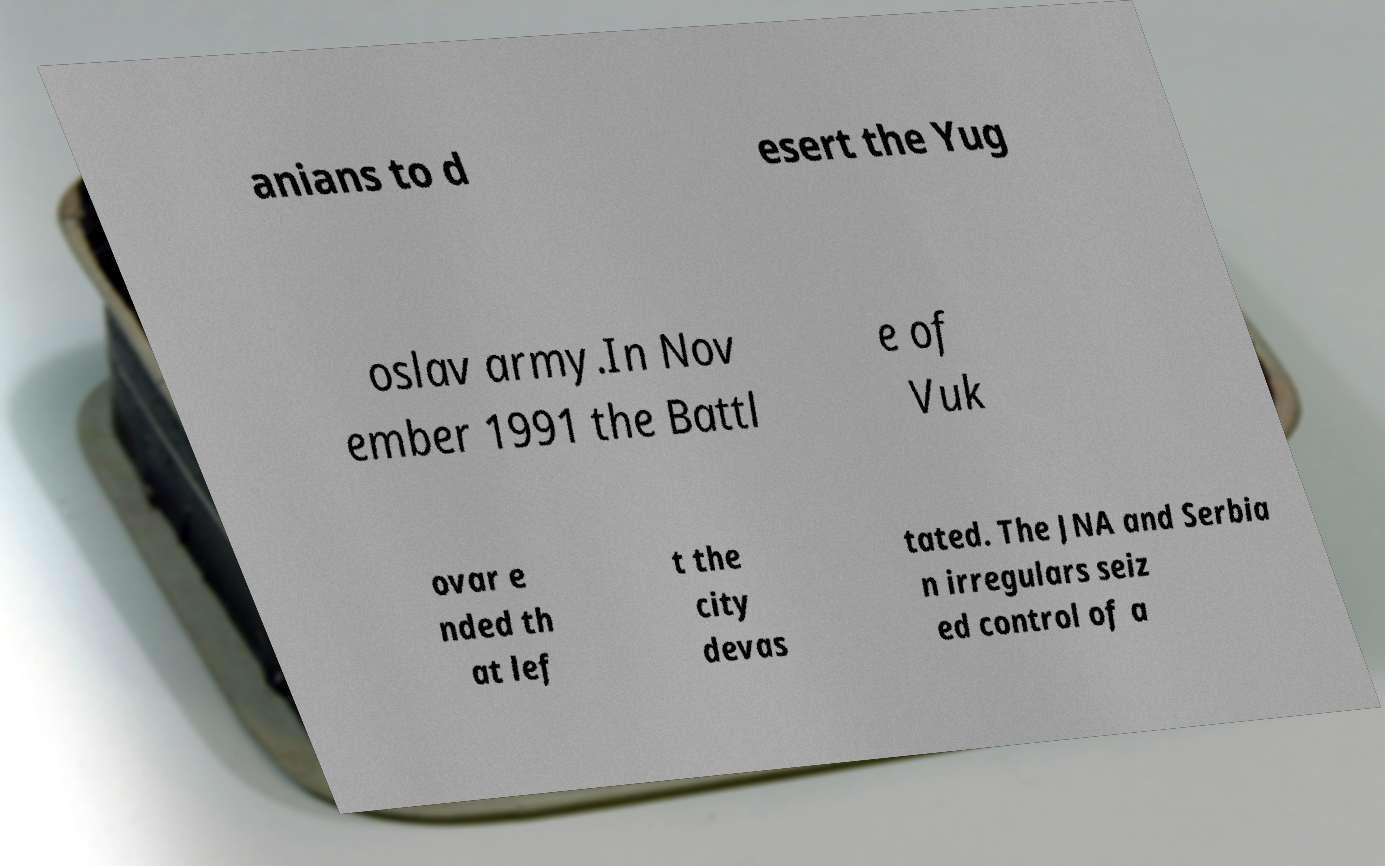Could you extract and type out the text from this image? anians to d esert the Yug oslav army.In Nov ember 1991 the Battl e of Vuk ovar e nded th at lef t the city devas tated. The JNA and Serbia n irregulars seiz ed control of a 